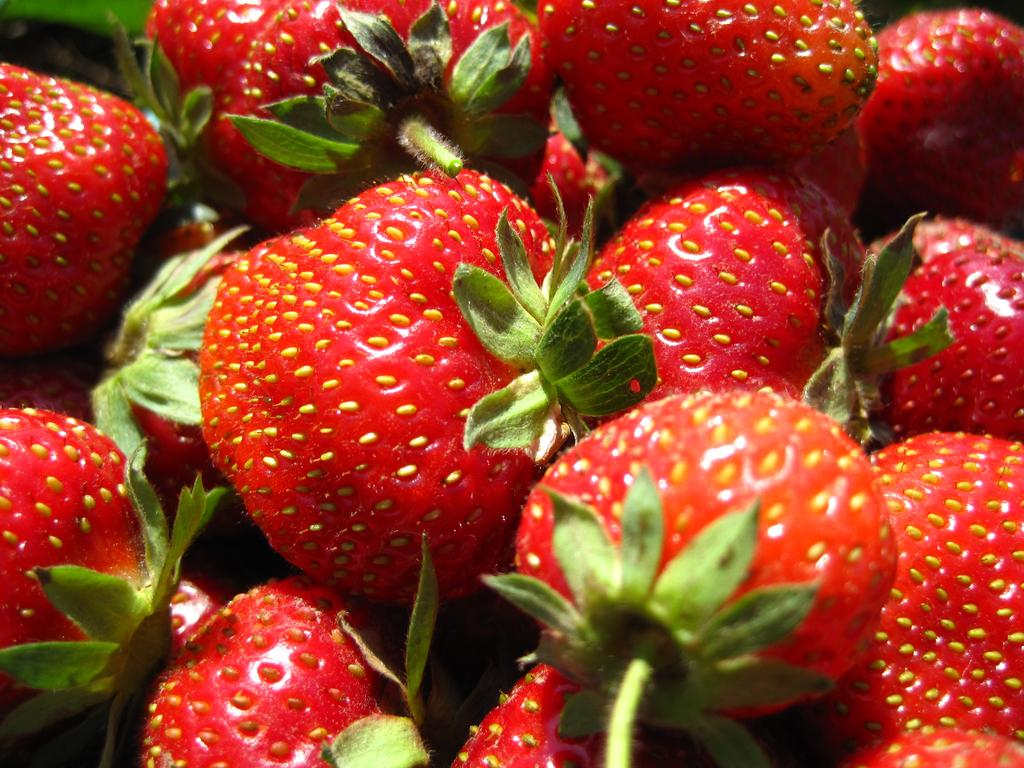What type of food can be seen in the image? There are fruits in the image. What is the monkey's purpose in the image? There is no monkey present in the image, so it is not possible to determine its purpose. 